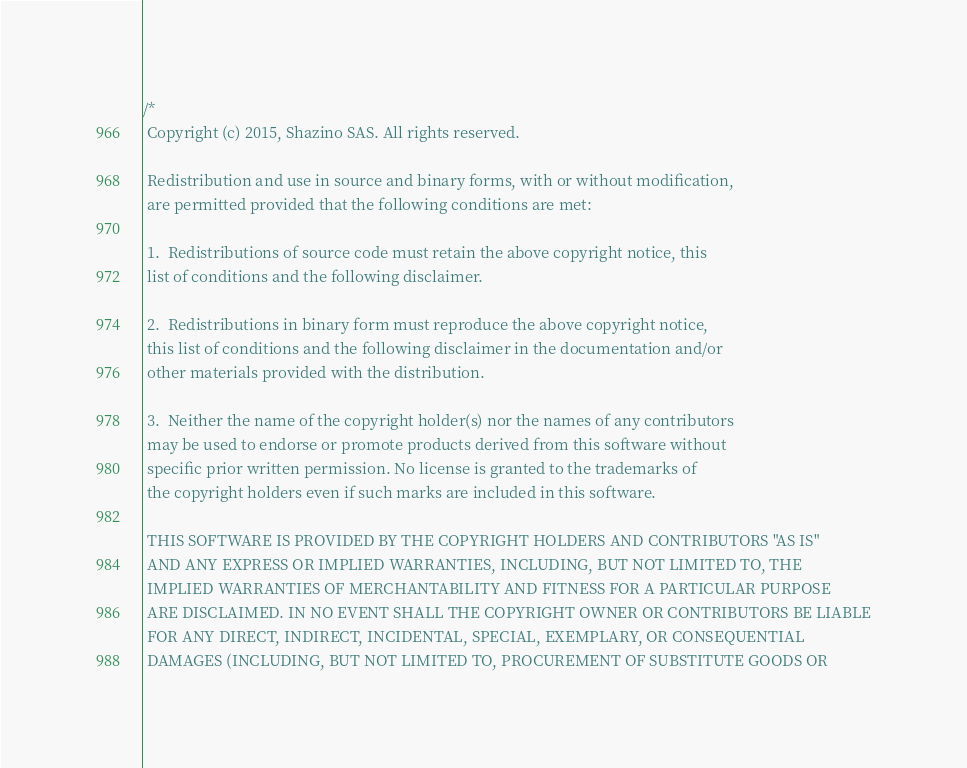<code> <loc_0><loc_0><loc_500><loc_500><_C_>/*
 Copyright (c) 2015, Shazino SAS. All rights reserved.
 
 Redistribution and use in source and binary forms, with or without modification,
 are permitted provided that the following conditions are met:
 
 1.  Redistributions of source code must retain the above copyright notice, this
 list of conditions and the following disclaimer.
 
 2.  Redistributions in binary form must reproduce the above copyright notice,
 this list of conditions and the following disclaimer in the documentation and/or
 other materials provided with the distribution.
 
 3.  Neither the name of the copyright holder(s) nor the names of any contributors
 may be used to endorse or promote products derived from this software without
 specific prior written permission. No license is granted to the trademarks of
 the copyright holders even if such marks are included in this software.
 
 THIS SOFTWARE IS PROVIDED BY THE COPYRIGHT HOLDERS AND CONTRIBUTORS "AS IS"
 AND ANY EXPRESS OR IMPLIED WARRANTIES, INCLUDING, BUT NOT LIMITED TO, THE
 IMPLIED WARRANTIES OF MERCHANTABILITY AND FITNESS FOR A PARTICULAR PURPOSE
 ARE DISCLAIMED. IN NO EVENT SHALL THE COPYRIGHT OWNER OR CONTRIBUTORS BE LIABLE
 FOR ANY DIRECT, INDIRECT, INCIDENTAL, SPECIAL, EXEMPLARY, OR CONSEQUENTIAL
 DAMAGES (INCLUDING, BUT NOT LIMITED TO, PROCUREMENT OF SUBSTITUTE GOODS OR</code> 